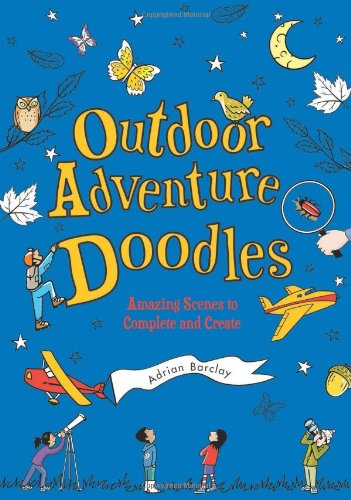What age group is this book intended for? This book is ideal for children aged 6 to 12, designed to engage them with age-appropriate doodling tasks and outdoor themes that capture their imagination. 